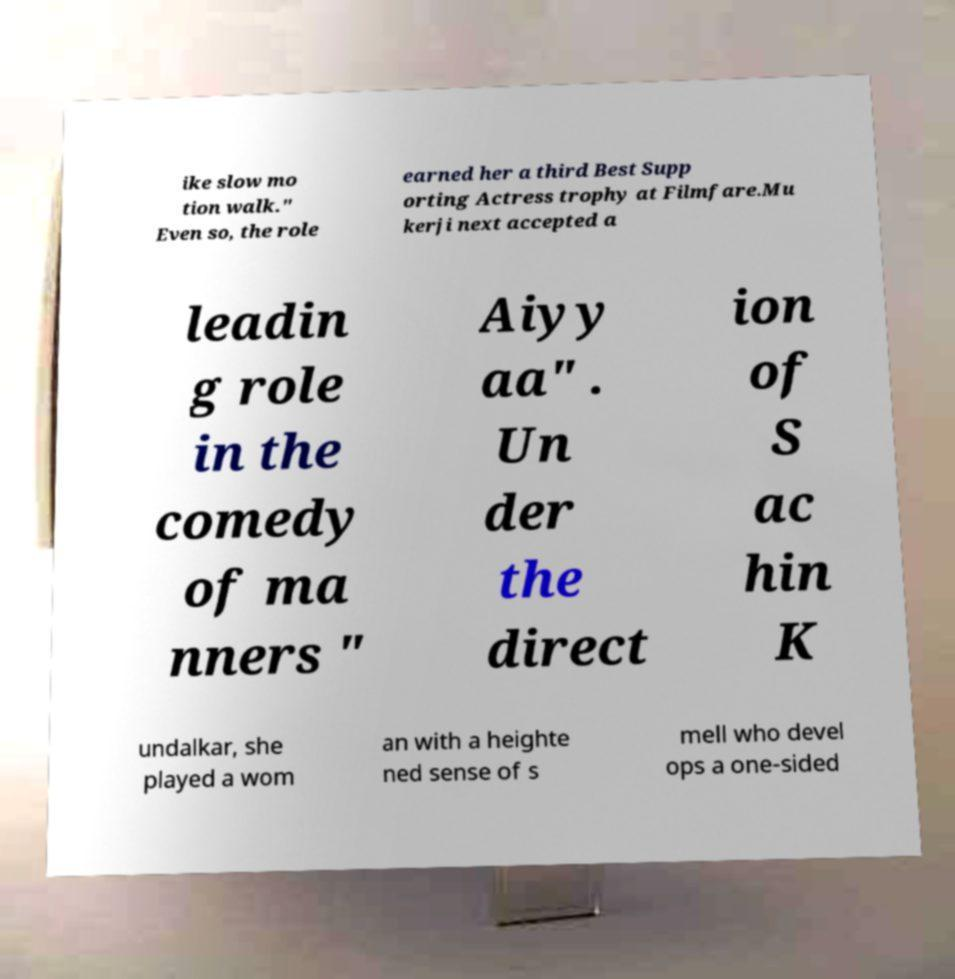Could you assist in decoding the text presented in this image and type it out clearly? ike slow mo tion walk." Even so, the role earned her a third Best Supp orting Actress trophy at Filmfare.Mu kerji next accepted a leadin g role in the comedy of ma nners " Aiyy aa" . Un der the direct ion of S ac hin K undalkar, she played a wom an with a heighte ned sense of s mell who devel ops a one-sided 